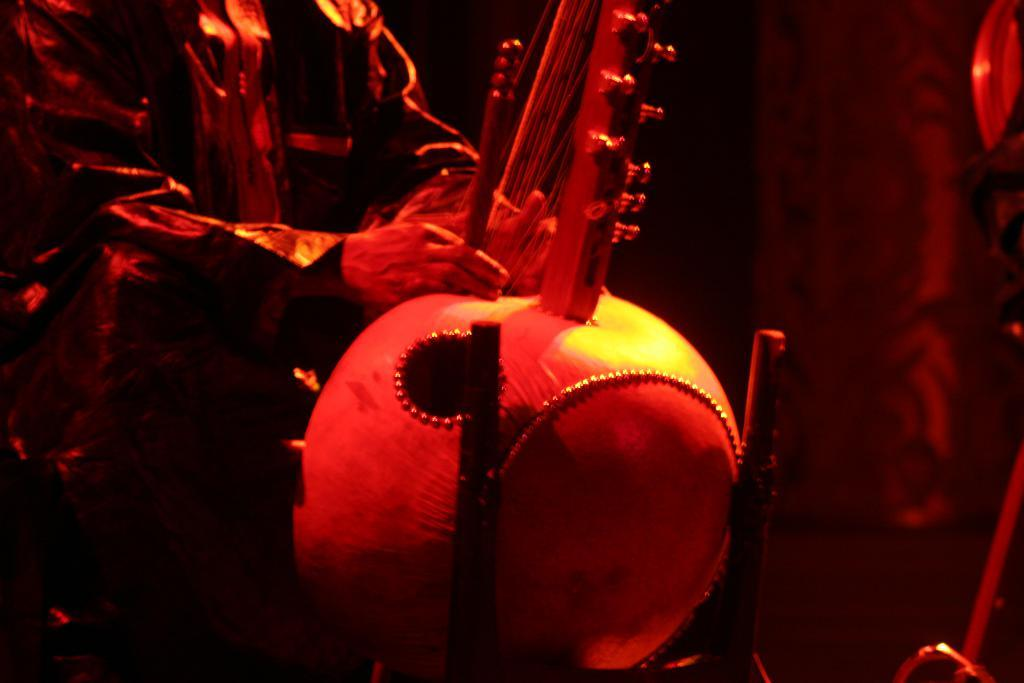What is the main subject of the image? There is a person in the image. What else can be seen in the image besides the person? There are objects in the image. Can you describe the background of the image? The background of the image is dark. How many cherries are on the hand in the image? There are no cherries or hands visible in the image. 